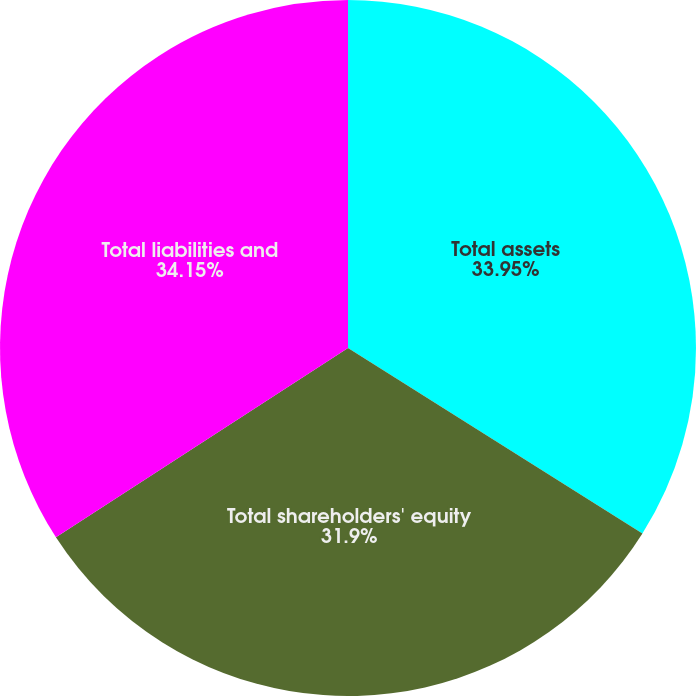<chart> <loc_0><loc_0><loc_500><loc_500><pie_chart><fcel>Total assets<fcel>Total shareholders' equity<fcel>Total liabilities and<nl><fcel>33.95%<fcel>31.9%<fcel>34.15%<nl></chart> 